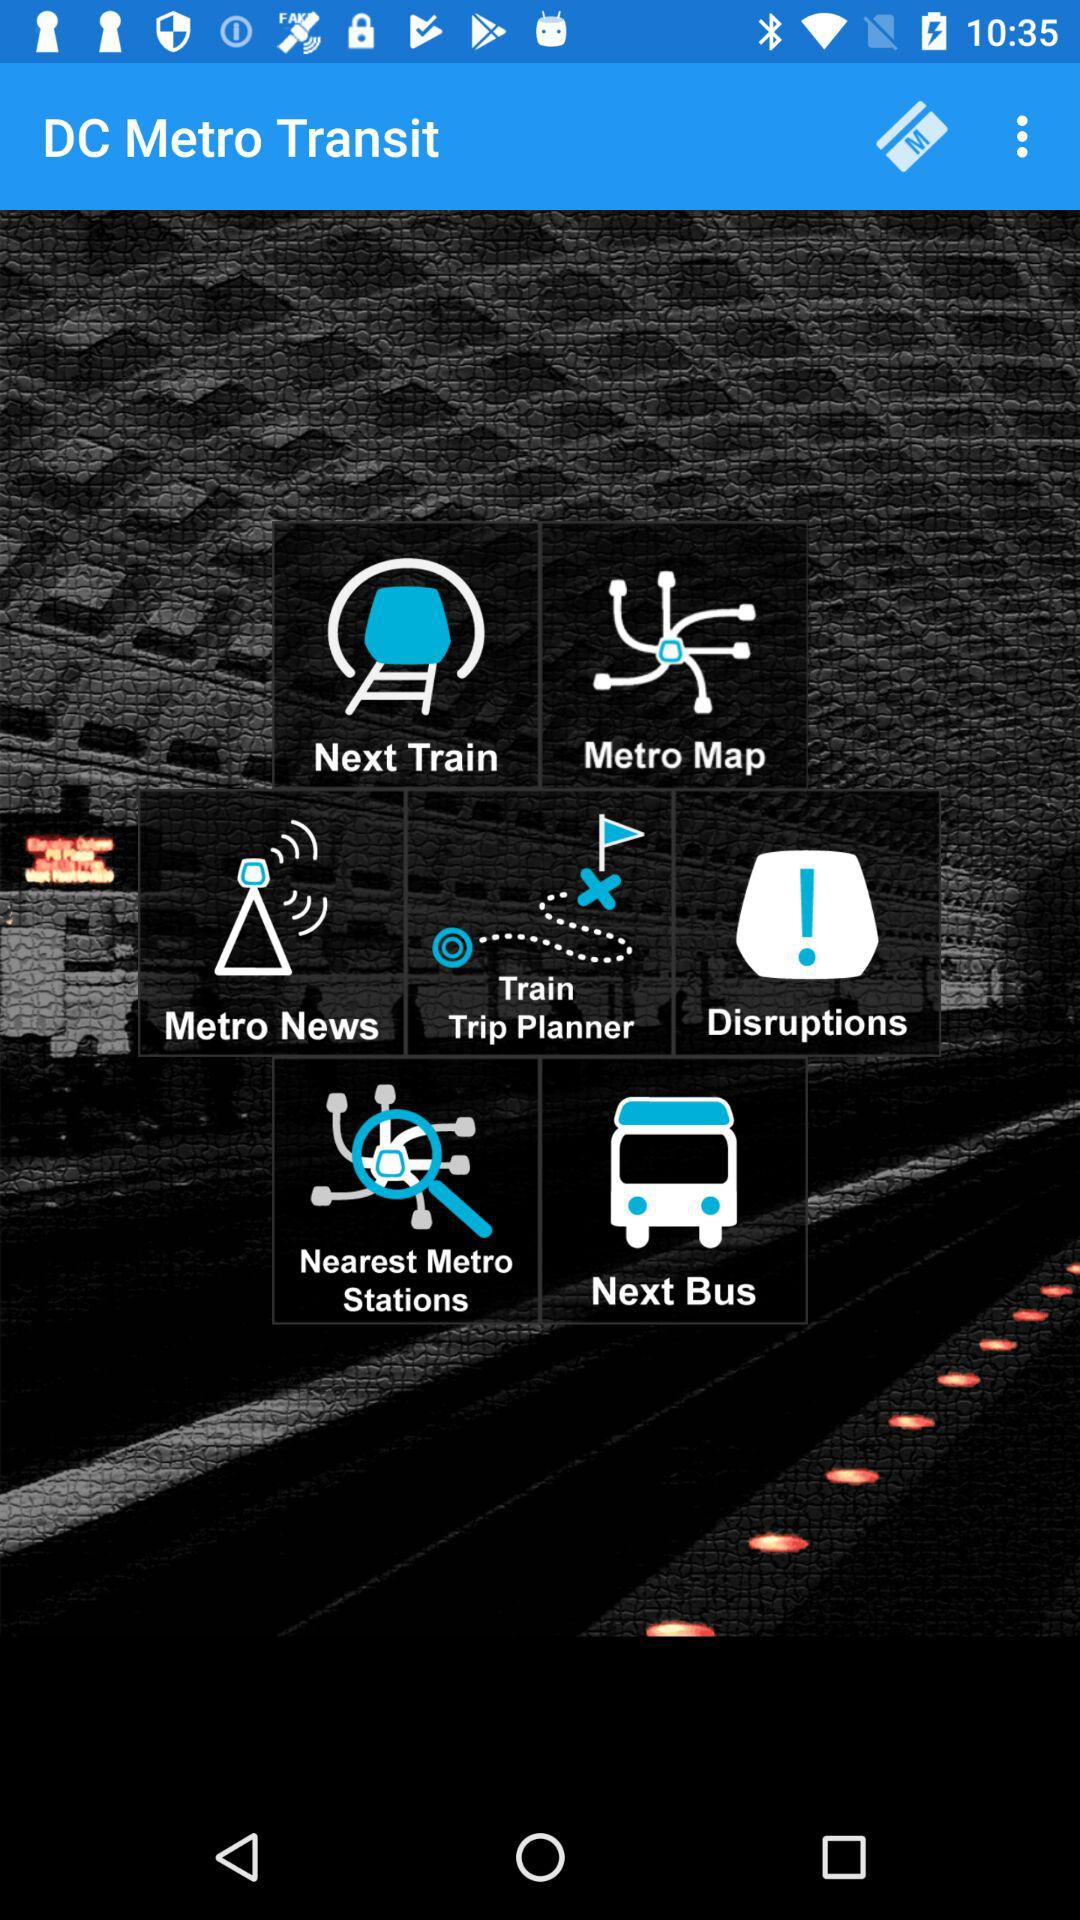What is the application name? The application name is "DC Metro Transit". 